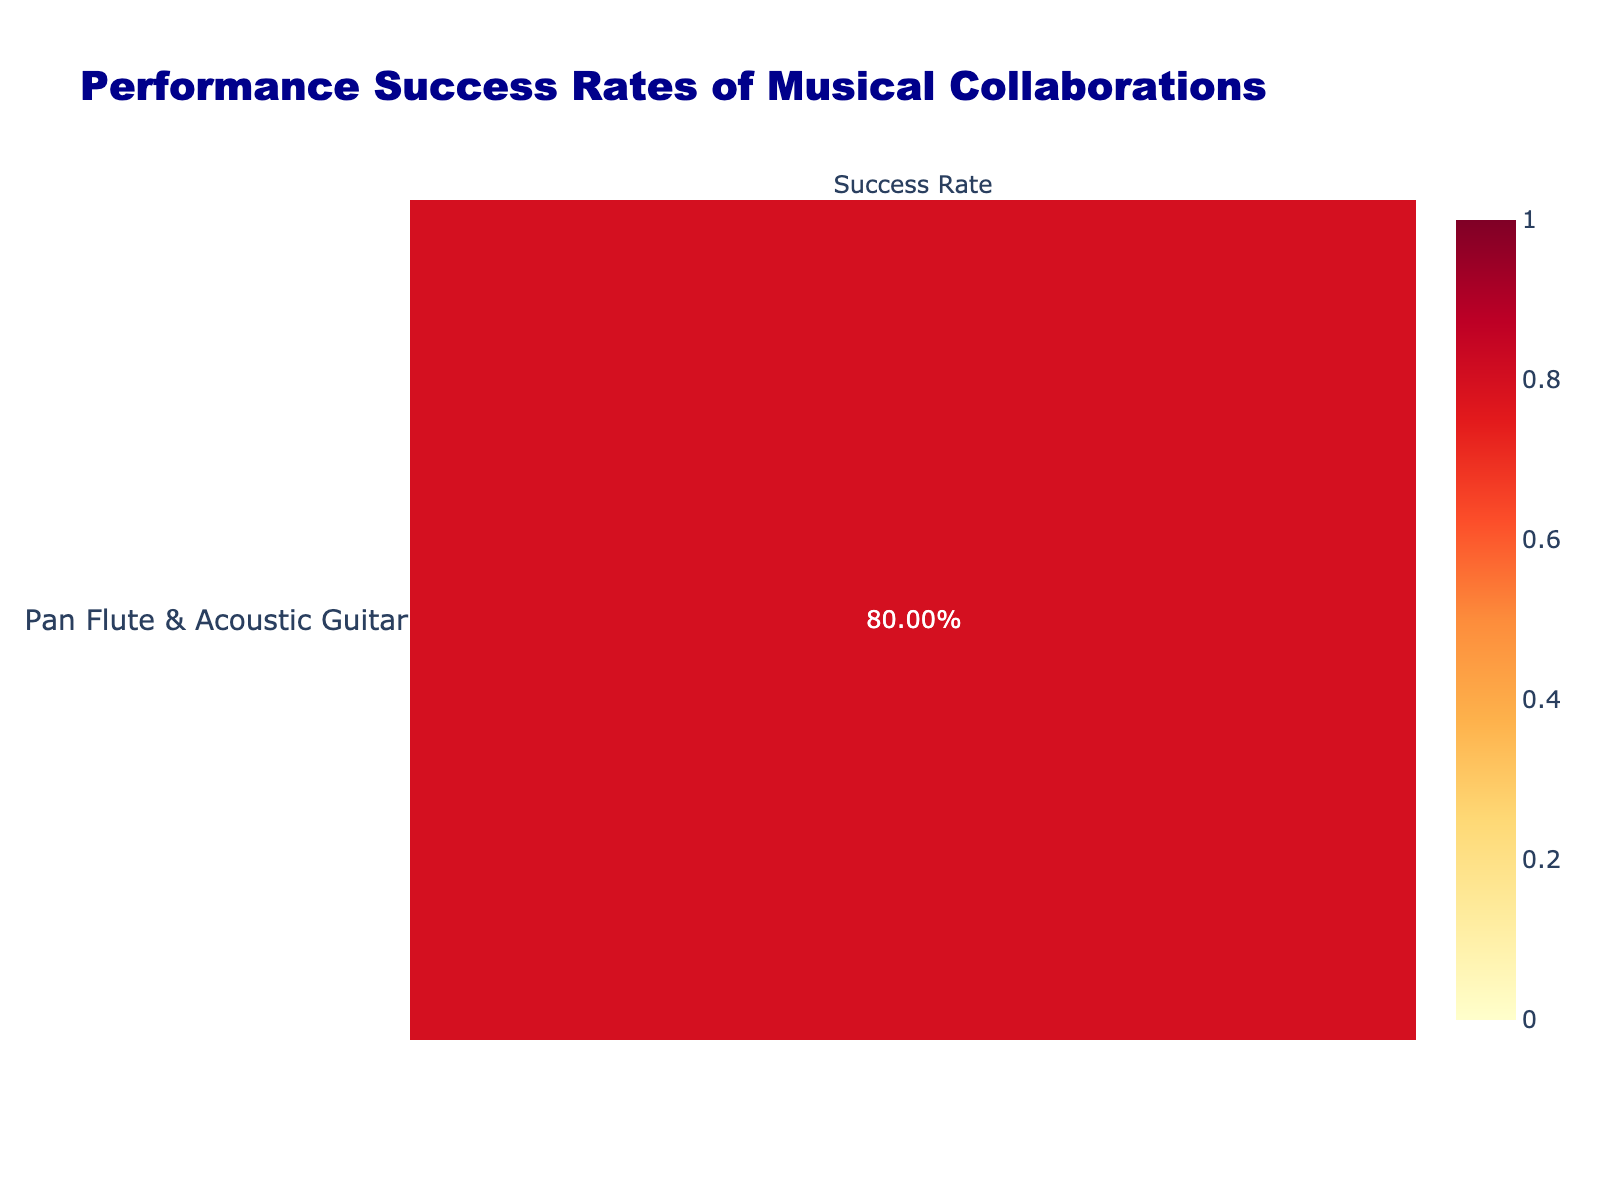What is the success rate of the collaboration between Pan Flute and Acoustic Guitar? The table shows the number of successful performances (40) and unsuccessful performances (10) for this collaboration type. The success rate is calculated by dividing the number of successful performances by the total performances, which is (40 / (40 + 10)) = 0.800 or 80%.
Answer: 80% Which musical collaboration has the highest success rate? By examining the table, the collaboration with the highest number of successful performances relative to total performances is "Guitar & Bass Guitar," with a success rate of (55 / (55 + 5)) = 0.917 or 91.7%.
Answer: Guitar & Bass Guitar What is the combined number of unsuccessful performances for all Pan Flute collaborations? To find the total unsuccessful performances for the Pan Flute collaborations, we add up the unsuccessful counts for each collaboration type: 10 (with Acoustic Guitar) + 20 (with Electric Guitar) + 15 (with Percussion) + 5 (with Violin) + 30 (with Digital Music Production) + 25 (with Traditional Drums) = 105.
Answer: 105 Is it true that the collaboration "Electric Guitar & Synthesizer" has a success rate above 90%? The success rate for "Electric Guitar & Synthesizer" is calculated as 45 successful performances out of a total of 50 performances, which gives a success rate of (45 / (45 + 5)) = 0.900 or 90%. Therefore, the statement is false.
Answer: No What is the average success rate of all collaborations involving Pan Flute? The success rates for Pan Flute collaborations are 80% (with Acoustic Guitar), 60% (with Electric Guitar), 62.5% (with Percussion), 88% (with Violin), 40% (with Digital Music Production), and 37.5% (with Traditional Drums). Adding these gives a total success rate of 80 + 60 + 62.5 + 88 + 40 + 37.5 = 368, and dividing by 6 collaborators gives an average of 368 / 6 = 61.33%.
Answer: 61.33% Which collaboration type has a lower success rate: Pan Flute & Digital Music Production or Acoustic Guitar & Cello? Calculating the success rates, Pan Flute & Digital Music Production has a success rate of (20 / (20 + 30)) = 0.400 or 40%, while Acoustic Guitar & Cello has (30 / (30 + 20)) = 0.600 or 60%. Therefore, Pan Flute & Digital Music Production has the lower success rate.
Answer: Pan Flute & Digital Music Production 